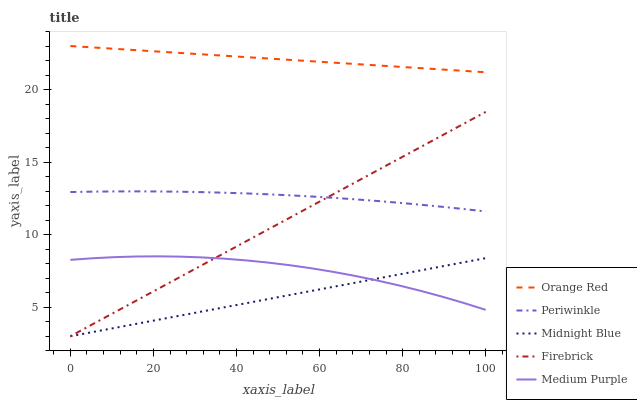Does Midnight Blue have the minimum area under the curve?
Answer yes or no. Yes. Does Orange Red have the maximum area under the curve?
Answer yes or no. Yes. Does Firebrick have the minimum area under the curve?
Answer yes or no. No. Does Firebrick have the maximum area under the curve?
Answer yes or no. No. Is Firebrick the smoothest?
Answer yes or no. Yes. Is Medium Purple the roughest?
Answer yes or no. Yes. Is Periwinkle the smoothest?
Answer yes or no. No. Is Periwinkle the roughest?
Answer yes or no. No. Does Firebrick have the lowest value?
Answer yes or no. Yes. Does Periwinkle have the lowest value?
Answer yes or no. No. Does Orange Red have the highest value?
Answer yes or no. Yes. Does Firebrick have the highest value?
Answer yes or no. No. Is Firebrick less than Orange Red?
Answer yes or no. Yes. Is Orange Red greater than Periwinkle?
Answer yes or no. Yes. Does Midnight Blue intersect Firebrick?
Answer yes or no. Yes. Is Midnight Blue less than Firebrick?
Answer yes or no. No. Is Midnight Blue greater than Firebrick?
Answer yes or no. No. Does Firebrick intersect Orange Red?
Answer yes or no. No. 